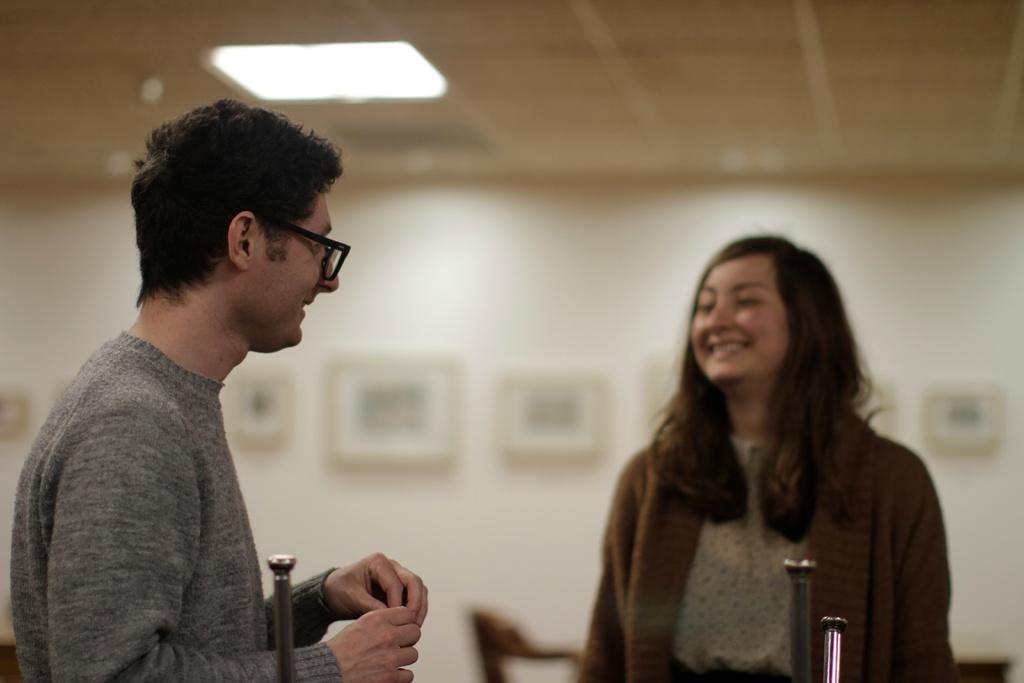How would you summarize this image in a sentence or two? In this image I see a man who is wearing grey t-shirt and I see that he is wearing spectacle and I see a woman over here and I see that both of them are smiling and I see that it is blurred in the background and I see the light on the ceiling and I see 3 silver color things in front. 